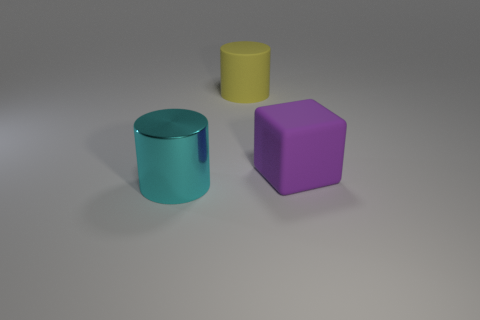What is the shape of the purple rubber object that is the same size as the yellow rubber cylinder?
Your answer should be compact. Cube. How many large things are cyan metallic cylinders or blue matte cylinders?
Your answer should be very brief. 1. There is another thing that is made of the same material as the big yellow object; what color is it?
Provide a succinct answer. Purple. There is a large object that is to the left of the yellow matte thing; does it have the same shape as the large rubber object that is left of the purple cube?
Provide a succinct answer. Yes. What number of matte things are gray things or large cubes?
Your answer should be very brief. 1. Are there any other things that are the same shape as the big purple thing?
Offer a terse response. No. What is the cylinder behind the shiny thing made of?
Ensure brevity in your answer.  Rubber. Do the object that is on the right side of the yellow thing and the big yellow thing have the same material?
Your answer should be compact. Yes. How many objects are cyan objects or cylinders behind the large cyan shiny cylinder?
Your response must be concise. 2. Are there any rubber cylinders right of the metal object?
Give a very brief answer. Yes. 